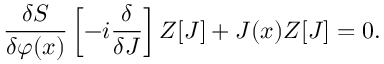<formula> <loc_0><loc_0><loc_500><loc_500>{ \frac { \delta S } { \delta \varphi ( x ) } } \left [ - i { \frac { \delta } { \delta J } } \right ] Z [ J ] + J ( x ) Z [ J ] = 0 .</formula> 